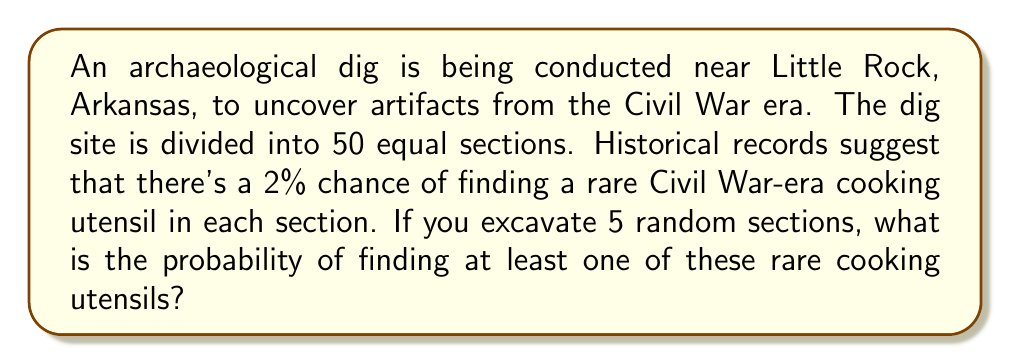Provide a solution to this math problem. Let's approach this step-by-step:

1) First, we need to calculate the probability of not finding the utensil in a single section:
   $P(\text{not finding utensil}) = 1 - P(\text{finding utensil}) = 1 - 0.02 = 0.98$

2) Now, we need to find the probability of not finding the utensil in all 5 sections:
   $P(\text{not finding utensil in 5 sections}) = 0.98^5$

3) We can calculate this:
   $0.98^5 \approx 0.9039$

4) The probability we're looking for is the opposite of this - the probability of finding at least one utensil. We can calculate this by subtracting our result from 1:

   $P(\text{finding at least one utensil}) = 1 - P(\text{not finding utensil in 5 sections})$
   $= 1 - 0.9039 \approx 0.0961$

5) Converting to a percentage:
   $0.0961 \times 100\% \approx 9.61\%$

Therefore, the probability of finding at least one rare Civil War-era cooking utensil when excavating 5 random sections is approximately 9.61%.
Answer: $9.61\%$ 